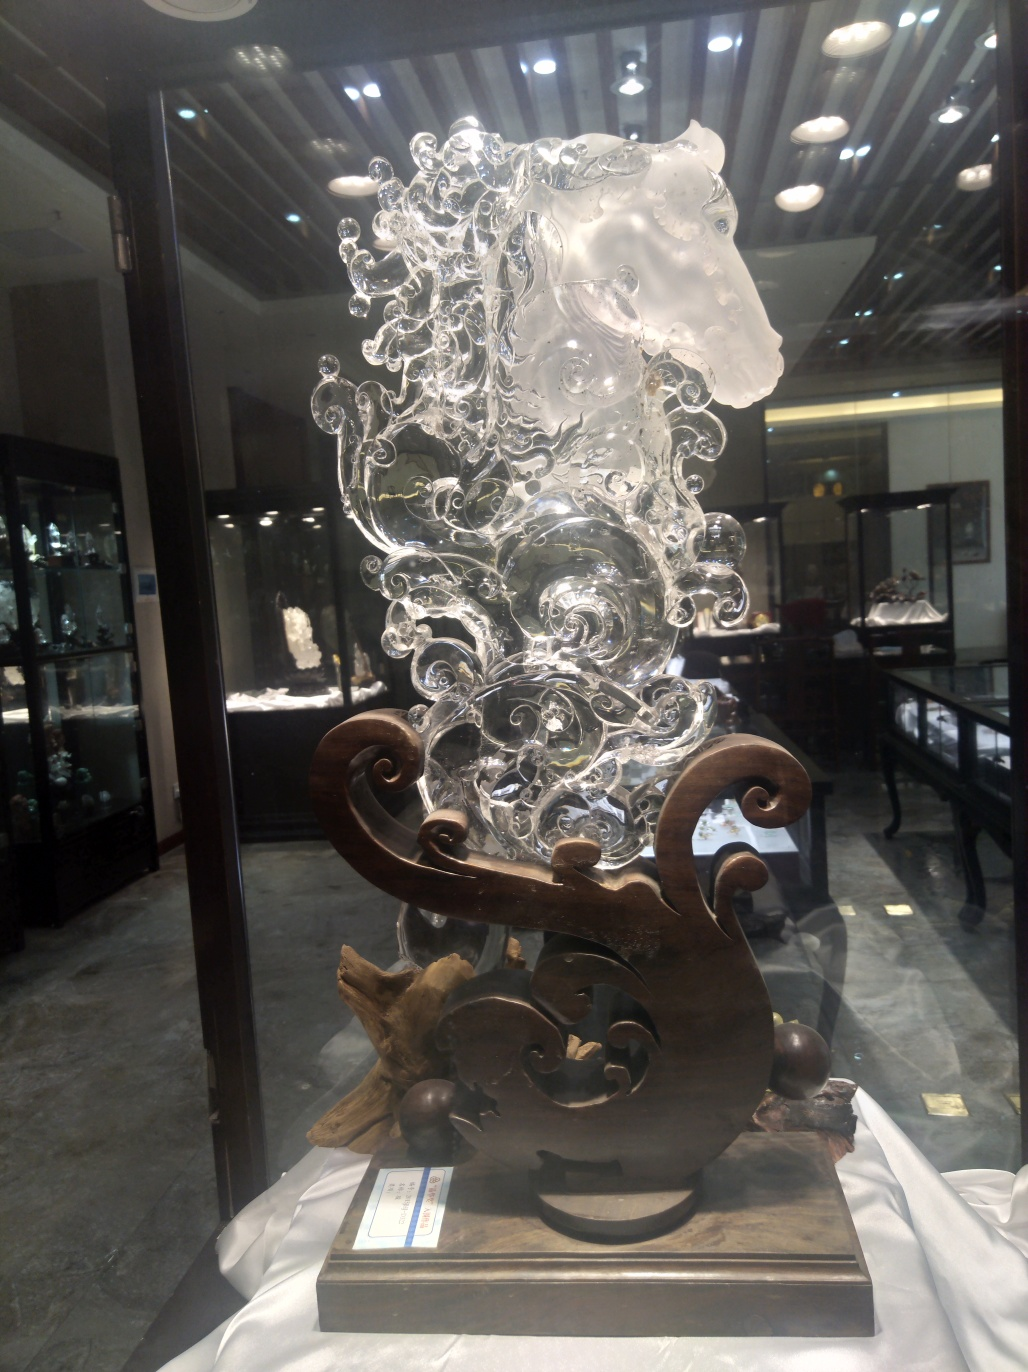Discuss and assess the quality of the picture, and form conclusions based on your evaluation. The photo exhibits a clear and detailed depiction of an intricate glass sculpture, possibly representing a wave or floral patterns complemented by a horse figure, suggesting a blend of nature and artistic imagination. The lighting and focus are well managed, highlighting the sculpture's transparent textures and complex contours. While the image's color palette is limited, primarily due to the nature of the material and the museum's lighting, this restraint actually emphasizes the delicacy and detail of the artwork. However, including different angles or closer details could provide a richer visual exploration and enhance viewer engagement with the art piece's exquisite craftsmanship. 